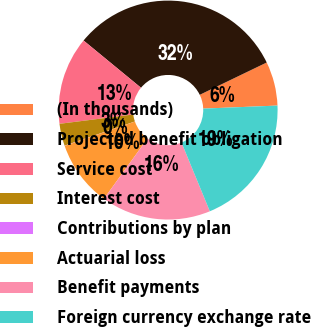<chart> <loc_0><loc_0><loc_500><loc_500><pie_chart><fcel>(In thousands)<fcel>Projected benefit obligation<fcel>Service cost<fcel>Interest cost<fcel>Contributions by plan<fcel>Actuarial loss<fcel>Benefit payments<fcel>Foreign currency exchange rate<nl><fcel>6.5%<fcel>31.89%<fcel>12.96%<fcel>3.27%<fcel>0.03%<fcel>9.73%<fcel>16.19%<fcel>19.43%<nl></chart> 